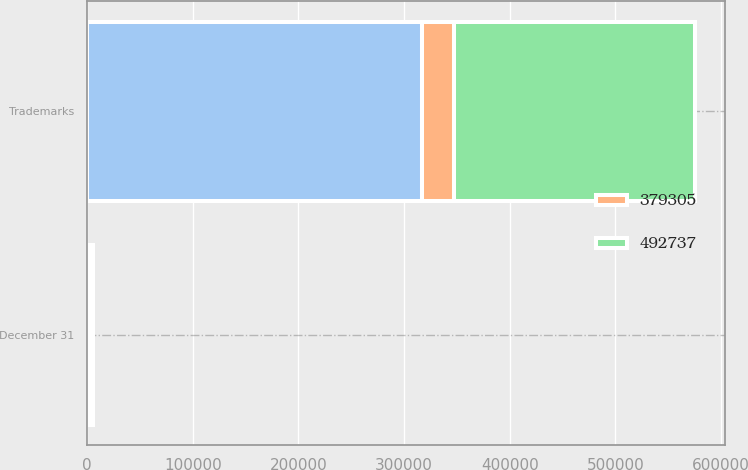Convert chart to OTSL. <chart><loc_0><loc_0><loc_500><loc_500><stacked_bar_chart><ecel><fcel>December 31<fcel>Trademarks<nl><fcel>nan<fcel>2016<fcel>317023<nl><fcel>379305<fcel>2016<fcel>30458<nl><fcel>492737<fcel>2015<fcel>227511<nl></chart> 